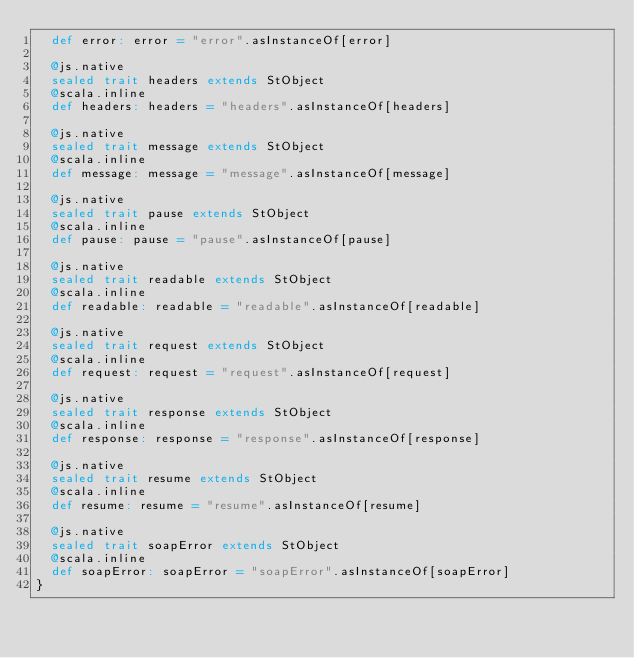<code> <loc_0><loc_0><loc_500><loc_500><_Scala_>  def error: error = "error".asInstanceOf[error]
  
  @js.native
  sealed trait headers extends StObject
  @scala.inline
  def headers: headers = "headers".asInstanceOf[headers]
  
  @js.native
  sealed trait message extends StObject
  @scala.inline
  def message: message = "message".asInstanceOf[message]
  
  @js.native
  sealed trait pause extends StObject
  @scala.inline
  def pause: pause = "pause".asInstanceOf[pause]
  
  @js.native
  sealed trait readable extends StObject
  @scala.inline
  def readable: readable = "readable".asInstanceOf[readable]
  
  @js.native
  sealed trait request extends StObject
  @scala.inline
  def request: request = "request".asInstanceOf[request]
  
  @js.native
  sealed trait response extends StObject
  @scala.inline
  def response: response = "response".asInstanceOf[response]
  
  @js.native
  sealed trait resume extends StObject
  @scala.inline
  def resume: resume = "resume".asInstanceOf[resume]
  
  @js.native
  sealed trait soapError extends StObject
  @scala.inline
  def soapError: soapError = "soapError".asInstanceOf[soapError]
}
</code> 